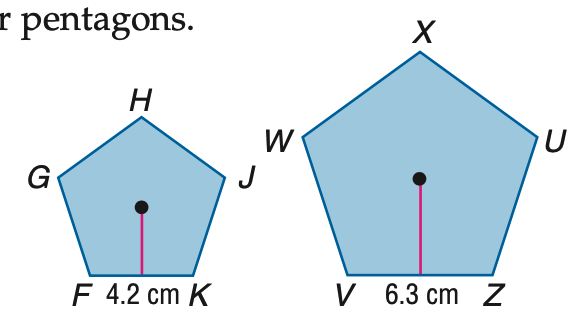Question: Polygons F G H J K and V W X U Z are similar regular pentagons. Find the scale factor.
Choices:
A. 1:2
B. 2:3
C. 3:2
D. 2:1
Answer with the letter. Answer: B 